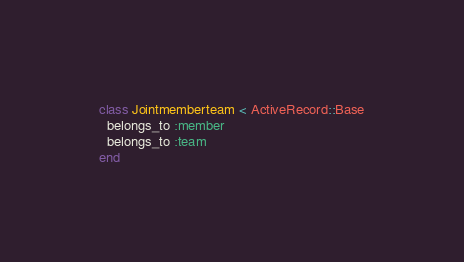<code> <loc_0><loc_0><loc_500><loc_500><_Ruby_>class Jointmemberteam < ActiveRecord::Base
  belongs_to :member
  belongs_to :team
end
</code> 